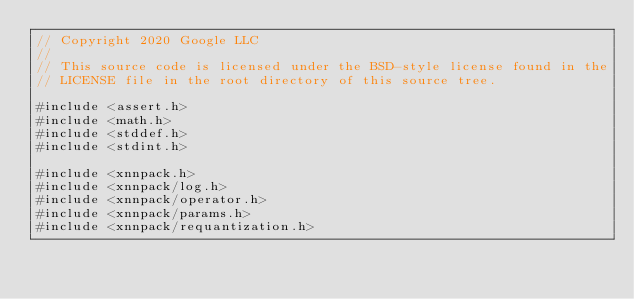<code> <loc_0><loc_0><loc_500><loc_500><_C_>// Copyright 2020 Google LLC
//
// This source code is licensed under the BSD-style license found in the
// LICENSE file in the root directory of this source tree.

#include <assert.h>
#include <math.h>
#include <stddef.h>
#include <stdint.h>

#include <xnnpack.h>
#include <xnnpack/log.h>
#include <xnnpack/operator.h>
#include <xnnpack/params.h>
#include <xnnpack/requantization.h></code> 